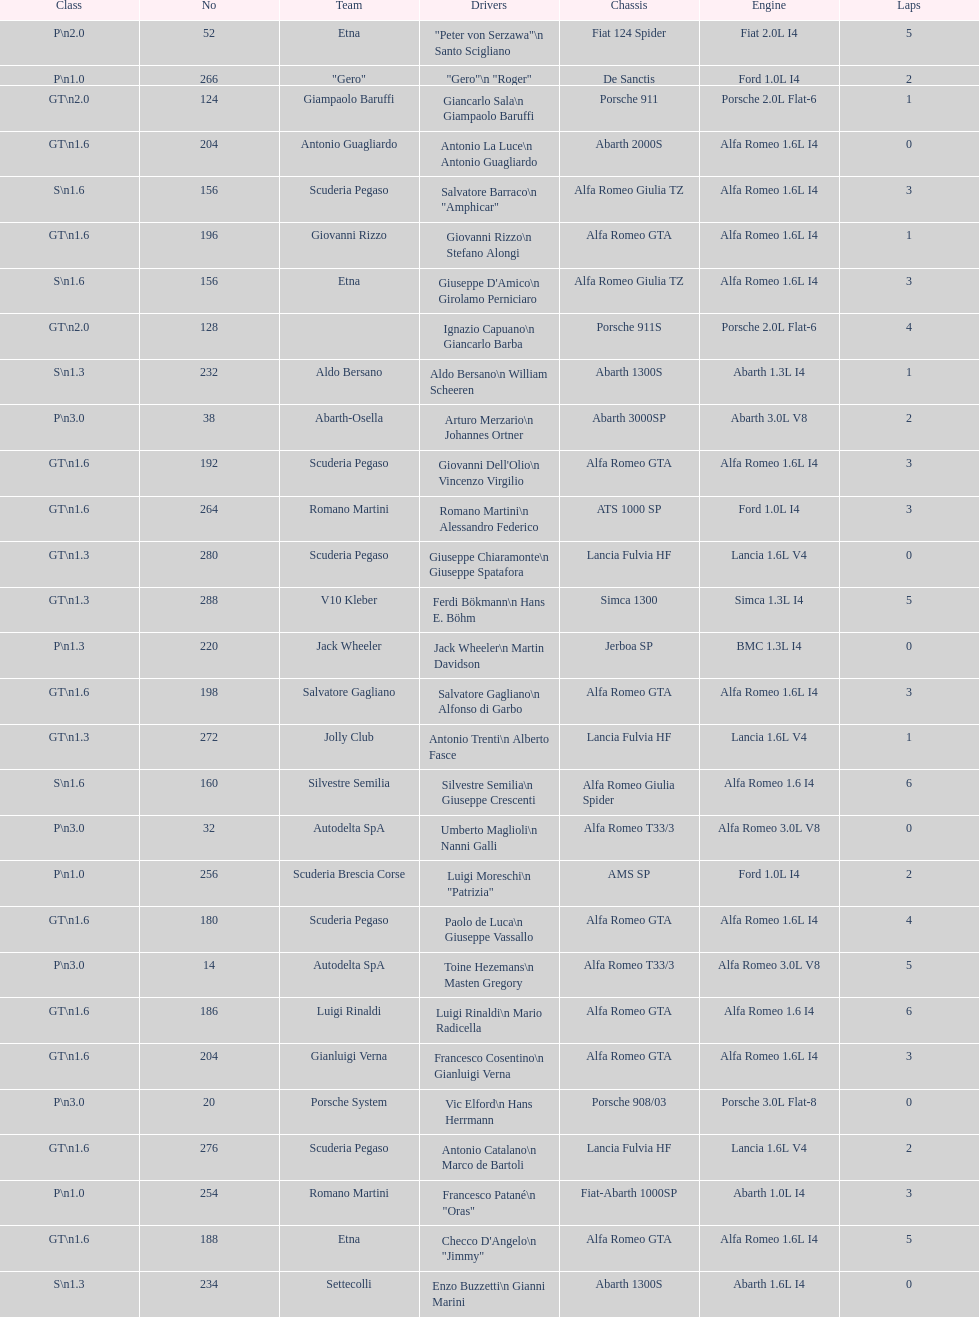How many drivers are from italy? 48. Could you parse the entire table as a dict? {'header': ['Class', 'No', 'Team', 'Drivers', 'Chassis', 'Engine', 'Laps'], 'rows': [['P\\n2.0', '52', 'Etna', '"Peter von Serzawa"\\n Santo Scigliano', 'Fiat 124 Spider', 'Fiat 2.0L I4', '5'], ['P\\n1.0', '266', '"Gero"', '"Gero"\\n "Roger"', 'De Sanctis', 'Ford 1.0L I4', '2'], ['GT\\n2.0', '124', 'Giampaolo Baruffi', 'Giancarlo Sala\\n Giampaolo Baruffi', 'Porsche 911', 'Porsche 2.0L Flat-6', '1'], ['GT\\n1.6', '204', 'Antonio Guagliardo', 'Antonio La Luce\\n Antonio Guagliardo', 'Abarth 2000S', 'Alfa Romeo 1.6L I4', '0'], ['S\\n1.6', '156', 'Scuderia Pegaso', 'Salvatore Barraco\\n "Amphicar"', 'Alfa Romeo Giulia TZ', 'Alfa Romeo 1.6L I4', '3'], ['GT\\n1.6', '196', 'Giovanni Rizzo', 'Giovanni Rizzo\\n Stefano Alongi', 'Alfa Romeo GTA', 'Alfa Romeo 1.6L I4', '1'], ['S\\n1.6', '156', 'Etna', "Giuseppe D'Amico\\n Girolamo Perniciaro", 'Alfa Romeo Giulia TZ', 'Alfa Romeo 1.6L I4', '3'], ['GT\\n2.0', '128', '', 'Ignazio Capuano\\n Giancarlo Barba', 'Porsche 911S', 'Porsche 2.0L Flat-6', '4'], ['S\\n1.3', '232', 'Aldo Bersano', 'Aldo Bersano\\n William Scheeren', 'Abarth 1300S', 'Abarth 1.3L I4', '1'], ['P\\n3.0', '38', 'Abarth-Osella', 'Arturo Merzario\\n Johannes Ortner', 'Abarth 3000SP', 'Abarth 3.0L V8', '2'], ['GT\\n1.6', '192', 'Scuderia Pegaso', "Giovanni Dell'Olio\\n Vincenzo Virgilio", 'Alfa Romeo GTA', 'Alfa Romeo 1.6L I4', '3'], ['GT\\n1.6', '264', 'Romano Martini', 'Romano Martini\\n Alessandro Federico', 'ATS 1000 SP', 'Ford 1.0L I4', '3'], ['GT\\n1.3', '280', 'Scuderia Pegaso', 'Giuseppe Chiaramonte\\n Giuseppe Spatafora', 'Lancia Fulvia HF', 'Lancia 1.6L V4', '0'], ['GT\\n1.3', '288', 'V10 Kleber', 'Ferdi Bökmann\\n Hans E. Böhm', 'Simca 1300', 'Simca 1.3L I4', '5'], ['P\\n1.3', '220', 'Jack Wheeler', 'Jack Wheeler\\n Martin Davidson', 'Jerboa SP', 'BMC 1.3L I4', '0'], ['GT\\n1.6', '198', 'Salvatore Gagliano', 'Salvatore Gagliano\\n Alfonso di Garbo', 'Alfa Romeo GTA', 'Alfa Romeo 1.6L I4', '3'], ['GT\\n1.3', '272', 'Jolly Club', 'Antonio Trenti\\n Alberto Fasce', 'Lancia Fulvia HF', 'Lancia 1.6L V4', '1'], ['S\\n1.6', '160', 'Silvestre Semilia', 'Silvestre Semilia\\n Giuseppe Crescenti', 'Alfa Romeo Giulia Spider', 'Alfa Romeo 1.6 I4', '6'], ['P\\n3.0', '32', 'Autodelta SpA', 'Umberto Maglioli\\n Nanni Galli', 'Alfa Romeo T33/3', 'Alfa Romeo 3.0L V8', '0'], ['P\\n1.0', '256', 'Scuderia Brescia Corse', 'Luigi Moreschi\\n "Patrizia"', 'AMS SP', 'Ford 1.0L I4', '2'], ['GT\\n1.6', '180', 'Scuderia Pegaso', 'Paolo de Luca\\n Giuseppe Vassallo', 'Alfa Romeo GTA', 'Alfa Romeo 1.6L I4', '4'], ['P\\n3.0', '14', 'Autodelta SpA', 'Toine Hezemans\\n Masten Gregory', 'Alfa Romeo T33/3', 'Alfa Romeo 3.0L V8', '5'], ['GT\\n1.6', '186', 'Luigi Rinaldi', 'Luigi Rinaldi\\n Mario Radicella', 'Alfa Romeo GTA', 'Alfa Romeo 1.6 I4', '6'], ['GT\\n1.6', '204', 'Gianluigi Verna', 'Francesco Cosentino\\n Gianluigi Verna', 'Alfa Romeo GTA', 'Alfa Romeo 1.6L I4', '3'], ['P\\n3.0', '20', 'Porsche System', 'Vic Elford\\n Hans Herrmann', 'Porsche 908/03', 'Porsche 3.0L Flat-8', '0'], ['GT\\n1.6', '276', 'Scuderia Pegaso', 'Antonio Catalano\\n Marco de Bartoli', 'Lancia Fulvia HF', 'Lancia 1.6L V4', '2'], ['P\\n1.0', '254', 'Romano Martini', 'Francesco Patané\\n "Oras"', 'Fiat-Abarth 1000SP', 'Abarth 1.0L I4', '3'], ['GT\\n1.6', '188', 'Etna', 'Checco D\'Angelo\\n "Jimmy"', 'Alfa Romeo GTA', 'Alfa Romeo 1.6L I4', '5'], ['S\\n1.3', '234', 'Settecolli', 'Enzo Buzzetti\\n Gianni Marini', 'Abarth 1300S', 'Abarth 1.6L I4', '0']]} 